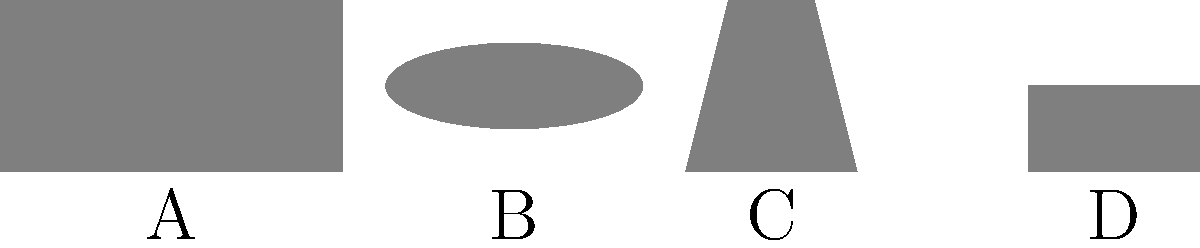Identify the traditional Cameroonian musical instrument represented by silhouette B in the image above. To identify the traditional Cameroonian musical instrument represented by silhouette B, let's analyze each silhouette:

1. Silhouette A: This rectangular shape with a flat bottom and top represents a balafon, a type of xylophone common in West and Central Africa.

2. Silhouette B: This elliptical shape represents the mvet, a traditional string instrument from Cameroon. The mvet is a harp-zither with an arched neck and an oval-shaped resonator, which matches the silhouette shown.

3. Silhouette C: This trapezoidal shape likely represents a tam-tam, a type of drum commonly used in Cameroonian traditional music.

4. Silhouette D: This rectangular shape probably represents the nkul, a slit drum used in Cameroonian traditional music and communication.

Given the elliptical shape and its resemblance to the mvet's distinctive form, silhouette B most likely represents the mvet.
Answer: Mvet 